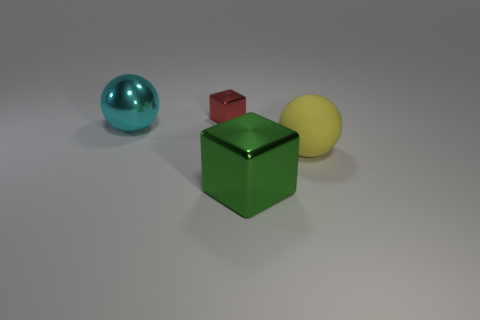Add 1 cyan shiny balls. How many objects exist? 5 Add 1 large green metal things. How many large green metal things are left? 2 Add 1 red blocks. How many red blocks exist? 2 Subtract 1 yellow balls. How many objects are left? 3 Subtract all big spheres. Subtract all big shiny cubes. How many objects are left? 1 